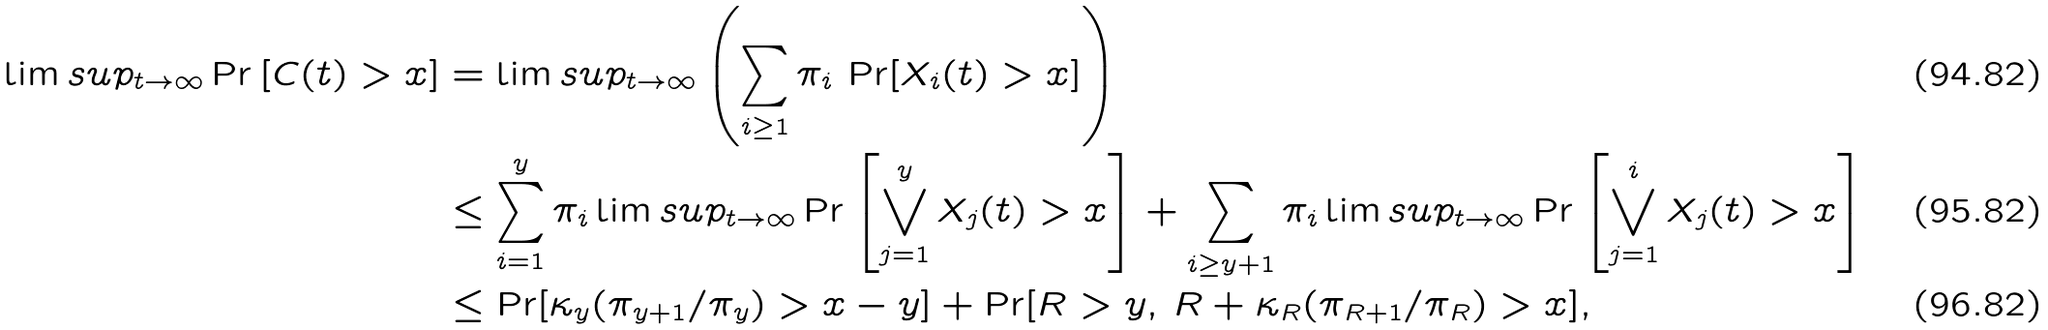<formula> <loc_0><loc_0><loc_500><loc_500>\lim s u p _ { t \to \infty } \Pr \left [ C ( t ) > x \right ] & = \lim s u p _ { t \to \infty } \left ( \sum _ { i \geq 1 } \pi _ { i } \, \Pr [ X _ { i } ( t ) > x ] \right ) \\ & \leq \sum _ { i = 1 } ^ { y } \pi _ { i } \lim s u p _ { t \to \infty } \Pr \left [ \bigvee _ { j = 1 } ^ { y } X _ { j } ( t ) > x \right ] + \sum _ { i \geq y + 1 } \pi _ { i } \lim s u p _ { t \to \infty } \Pr \left [ \bigvee _ { j = 1 } ^ { i } X _ { j } ( t ) > x \right ] \\ & \leq \Pr [ \kappa _ { y } ( \pi _ { y + 1 } / \pi _ { y } ) > x - y ] + \Pr [ R > y , \, R + \kappa _ { R } ( \pi _ { R + 1 } / \pi _ { R } ) > x ] ,</formula> 